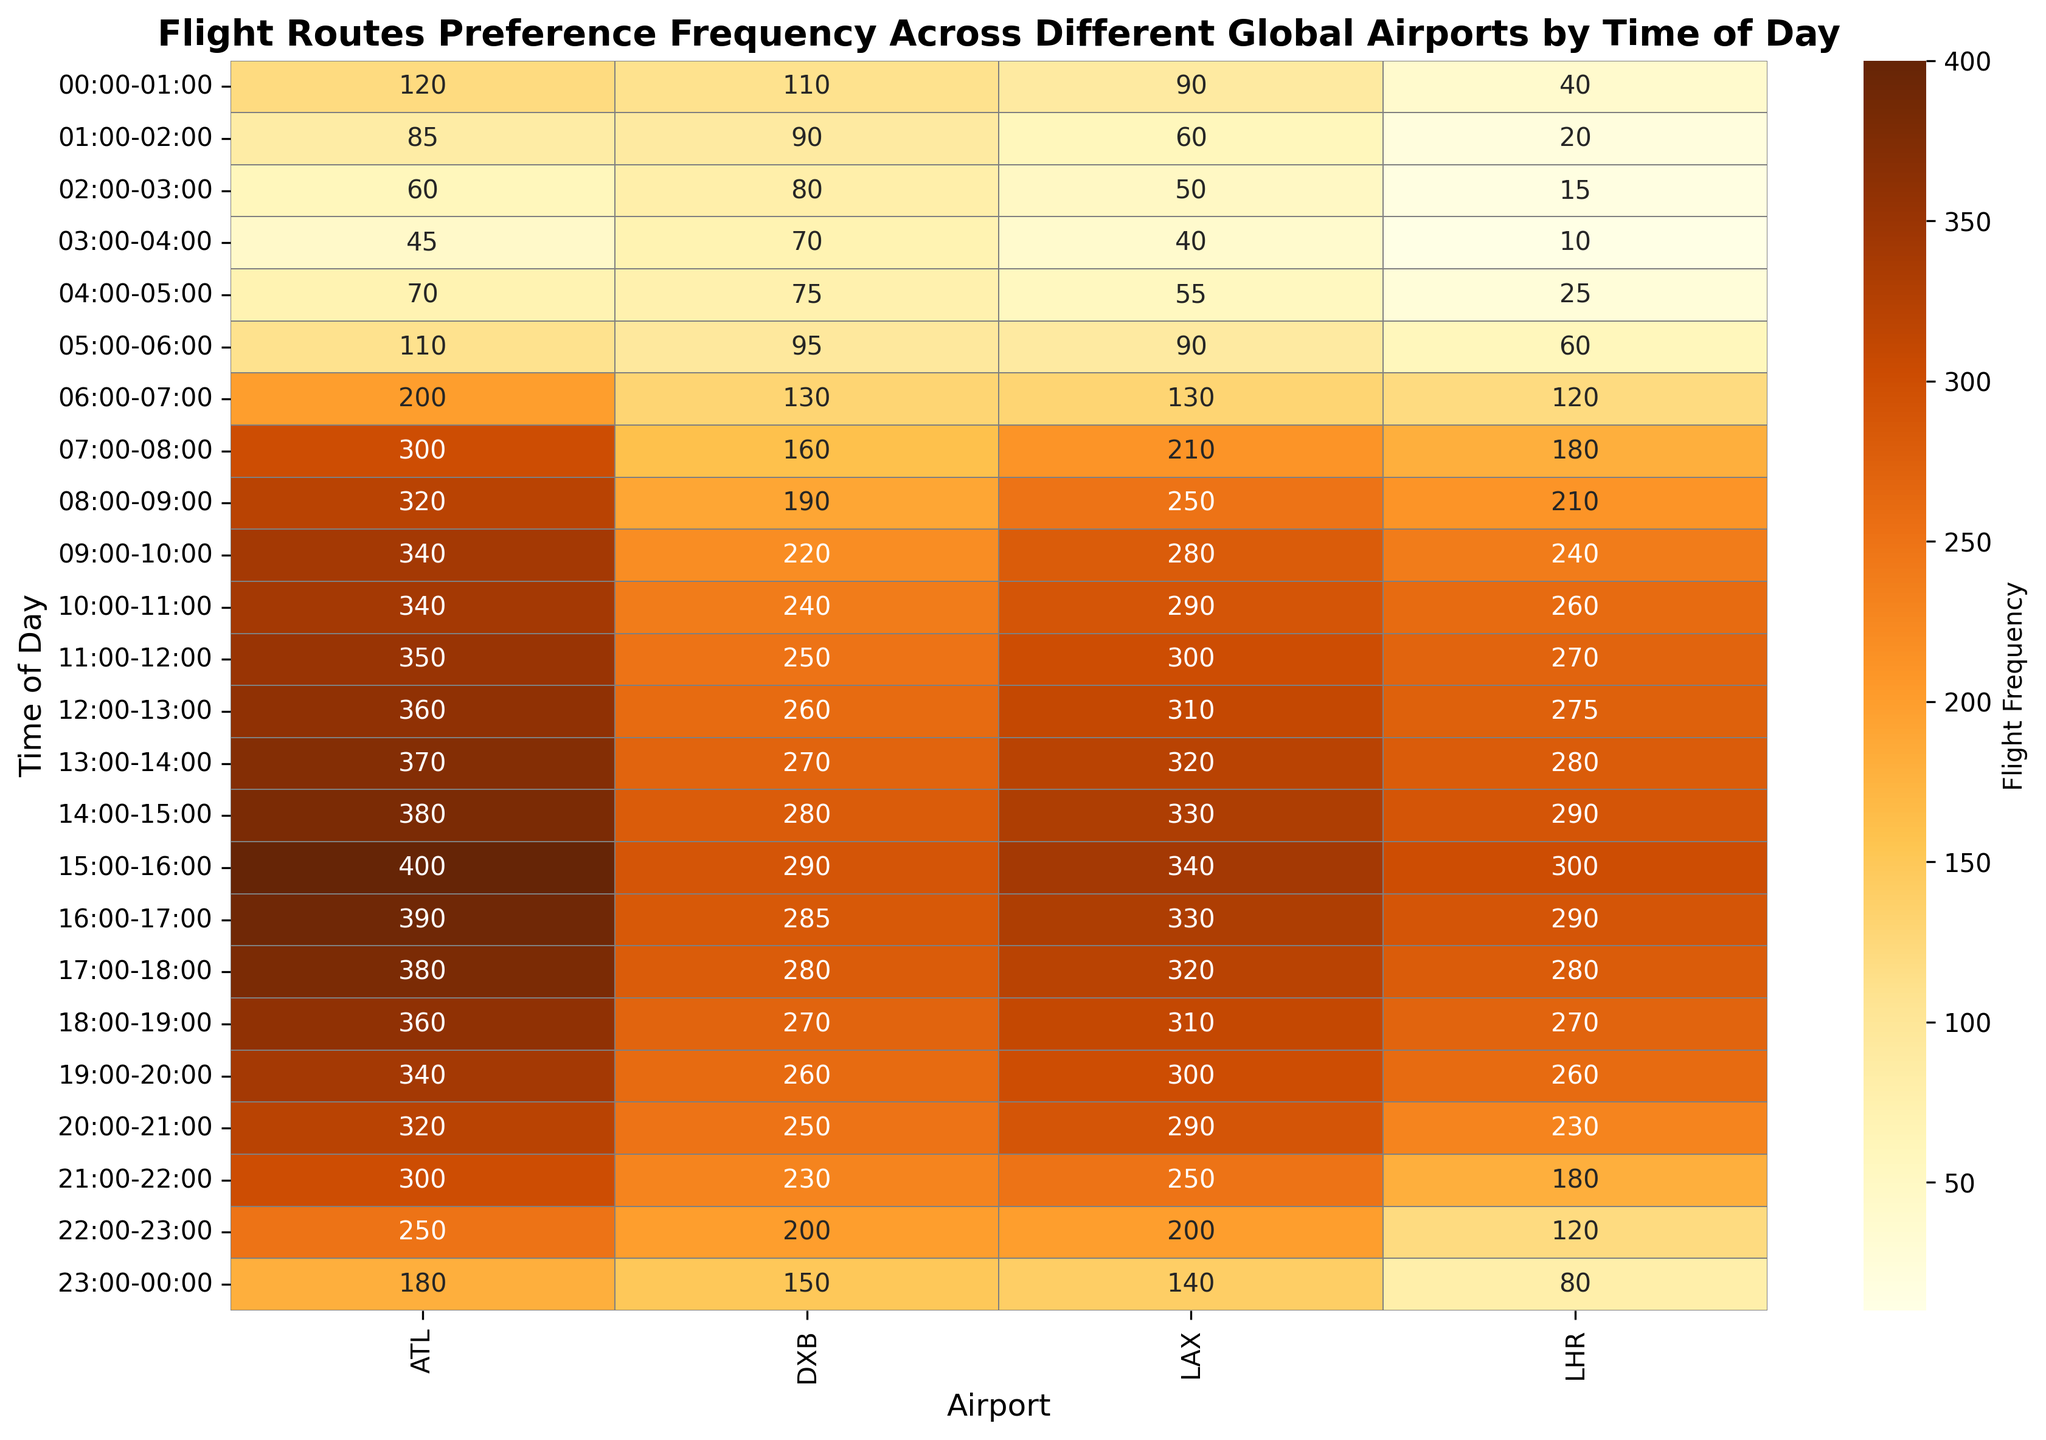Which airport has the highest flight frequency at 15:00-16:00? Looking at the 15:00-16:00 row, the airport with the highest frequency value is ATL with a frequency of 400
Answer: ATL How does the flight frequency at LAX compare to ATL at 10:00-11:00? At 10:00-11:00, ATL has a frequency of 340, while LAX has a frequency of 290. Therefore, ATL has a higher frequency than LAX at this time
Answer: ATL has a higher frequency What is the total frequency of flights at ATL between 07:00-12:00? Summing up the frequencies for ATL from 07:00-12:00: 300 + 320 + 340 + 340 + 350 + 360 = 2010
Answer: 2010 Which airport has the lowest average flight frequency across all times? To find the lowest average frequency, calculate the average for each airport across all times and compare. After summing the frequencies and dividing by 24 hours for each airport, LHR has the lowest average
Answer: LHR What color indicates the highest flight frequencies in the heatmap? The color that indicates the highest flight frequencies on a heatmap using the 'YlOrBr' colormap is a darker shade of brown
Answer: Dark brown At what time does LHR start seeing flight frequencies above 100? Looking at the LHR row, flight frequencies start to exceed 100 at the 05:00-06:00 slot
Answer: 05:00-06:00 What is the difference in frequency between the peak time and the lowest time for DXB? For DXB, the peak frequency is 290 at 15:00-16:00, and the lowest is 70 at 03:00-04:00. The difference is 290 - 70 = 220
Answer: 220 Which time slot has the least flight activity across all airports? Examine all rows, and the 03:00-04:00 slot has the least flight activity with the lowest values, specifically LHR at 10 flights
Answer: 03:00-04:00 What is the relative flight frequency trend at ATL from 00:00 to 06:00? From 00:00-06:00 at ATL, the frequency trends start at 120, drop to 85, 60, 45, then slight rise to 70, and substantial rise to 110. It shows an initial decrease followed by a rise
Answer: Decrease then rise Comparing LAX and DXB, who has more frequent flights in the evening (18:00-21:00)? For LAX at 18:00-21:00, frequencies are 310, 300, and 290 summing to 900. For DXB, frequencies are 270, 260, and 250 summing to 780
Answer: LAX 